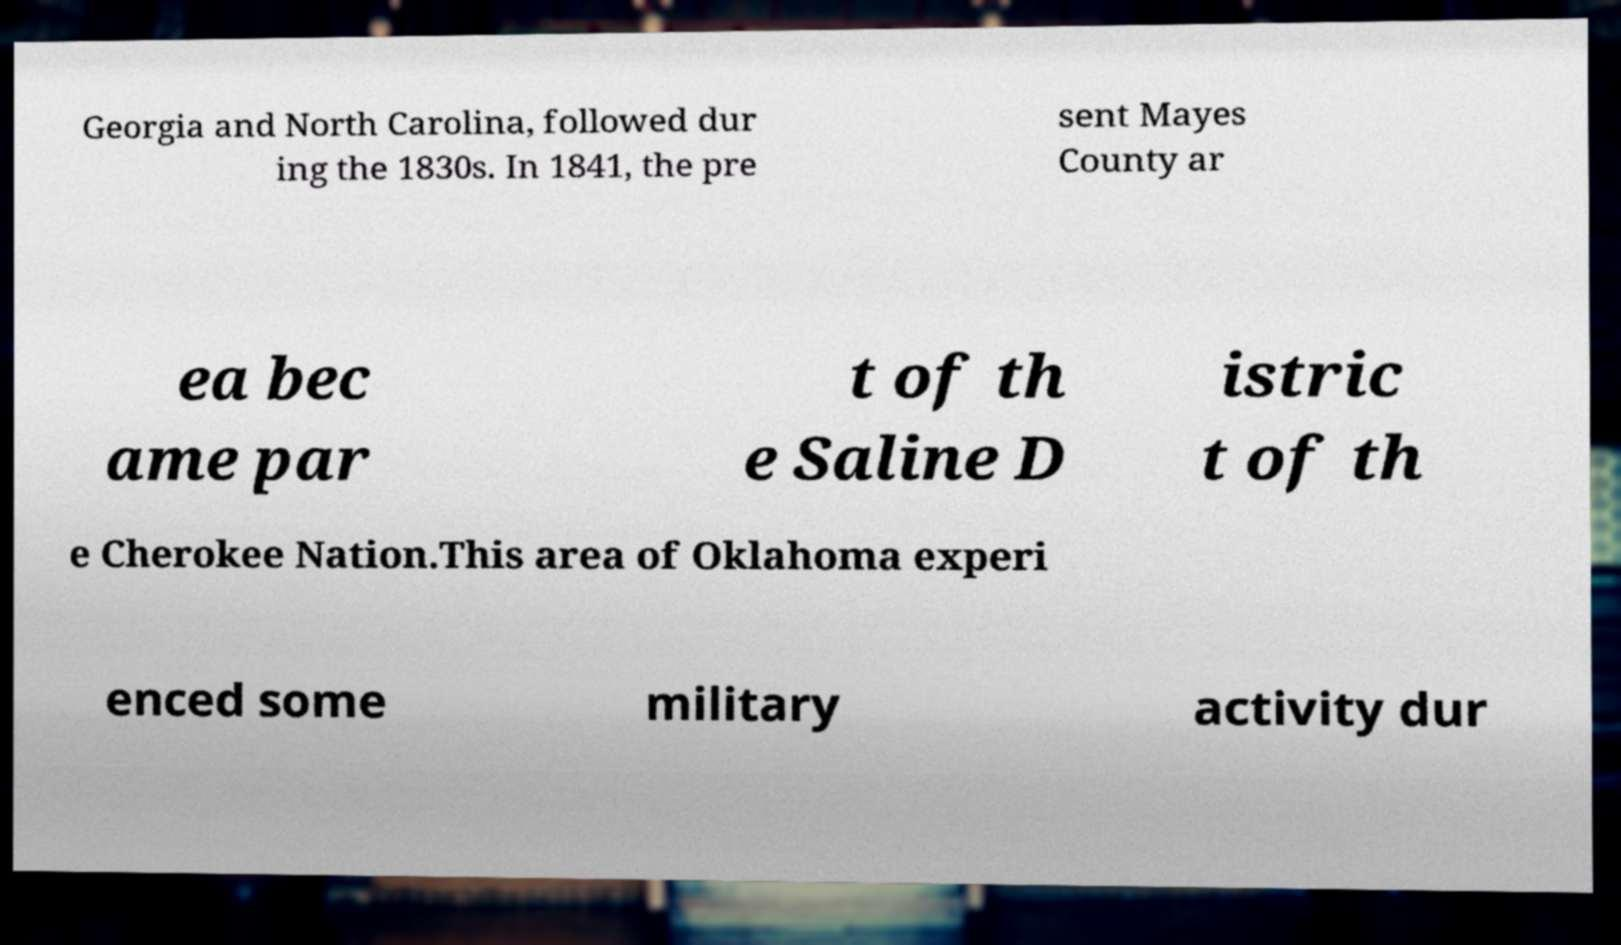Can you read and provide the text displayed in the image?This photo seems to have some interesting text. Can you extract and type it out for me? Georgia and North Carolina, followed dur ing the 1830s. In 1841, the pre sent Mayes County ar ea bec ame par t of th e Saline D istric t of th e Cherokee Nation.This area of Oklahoma experi enced some military activity dur 